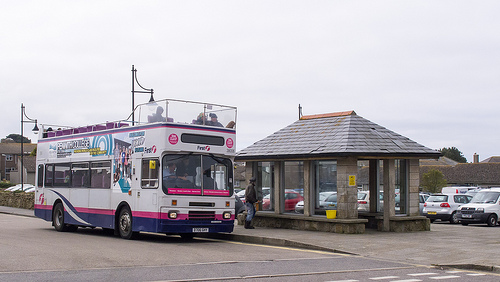How is the weather? The weather appears to be overcast. 